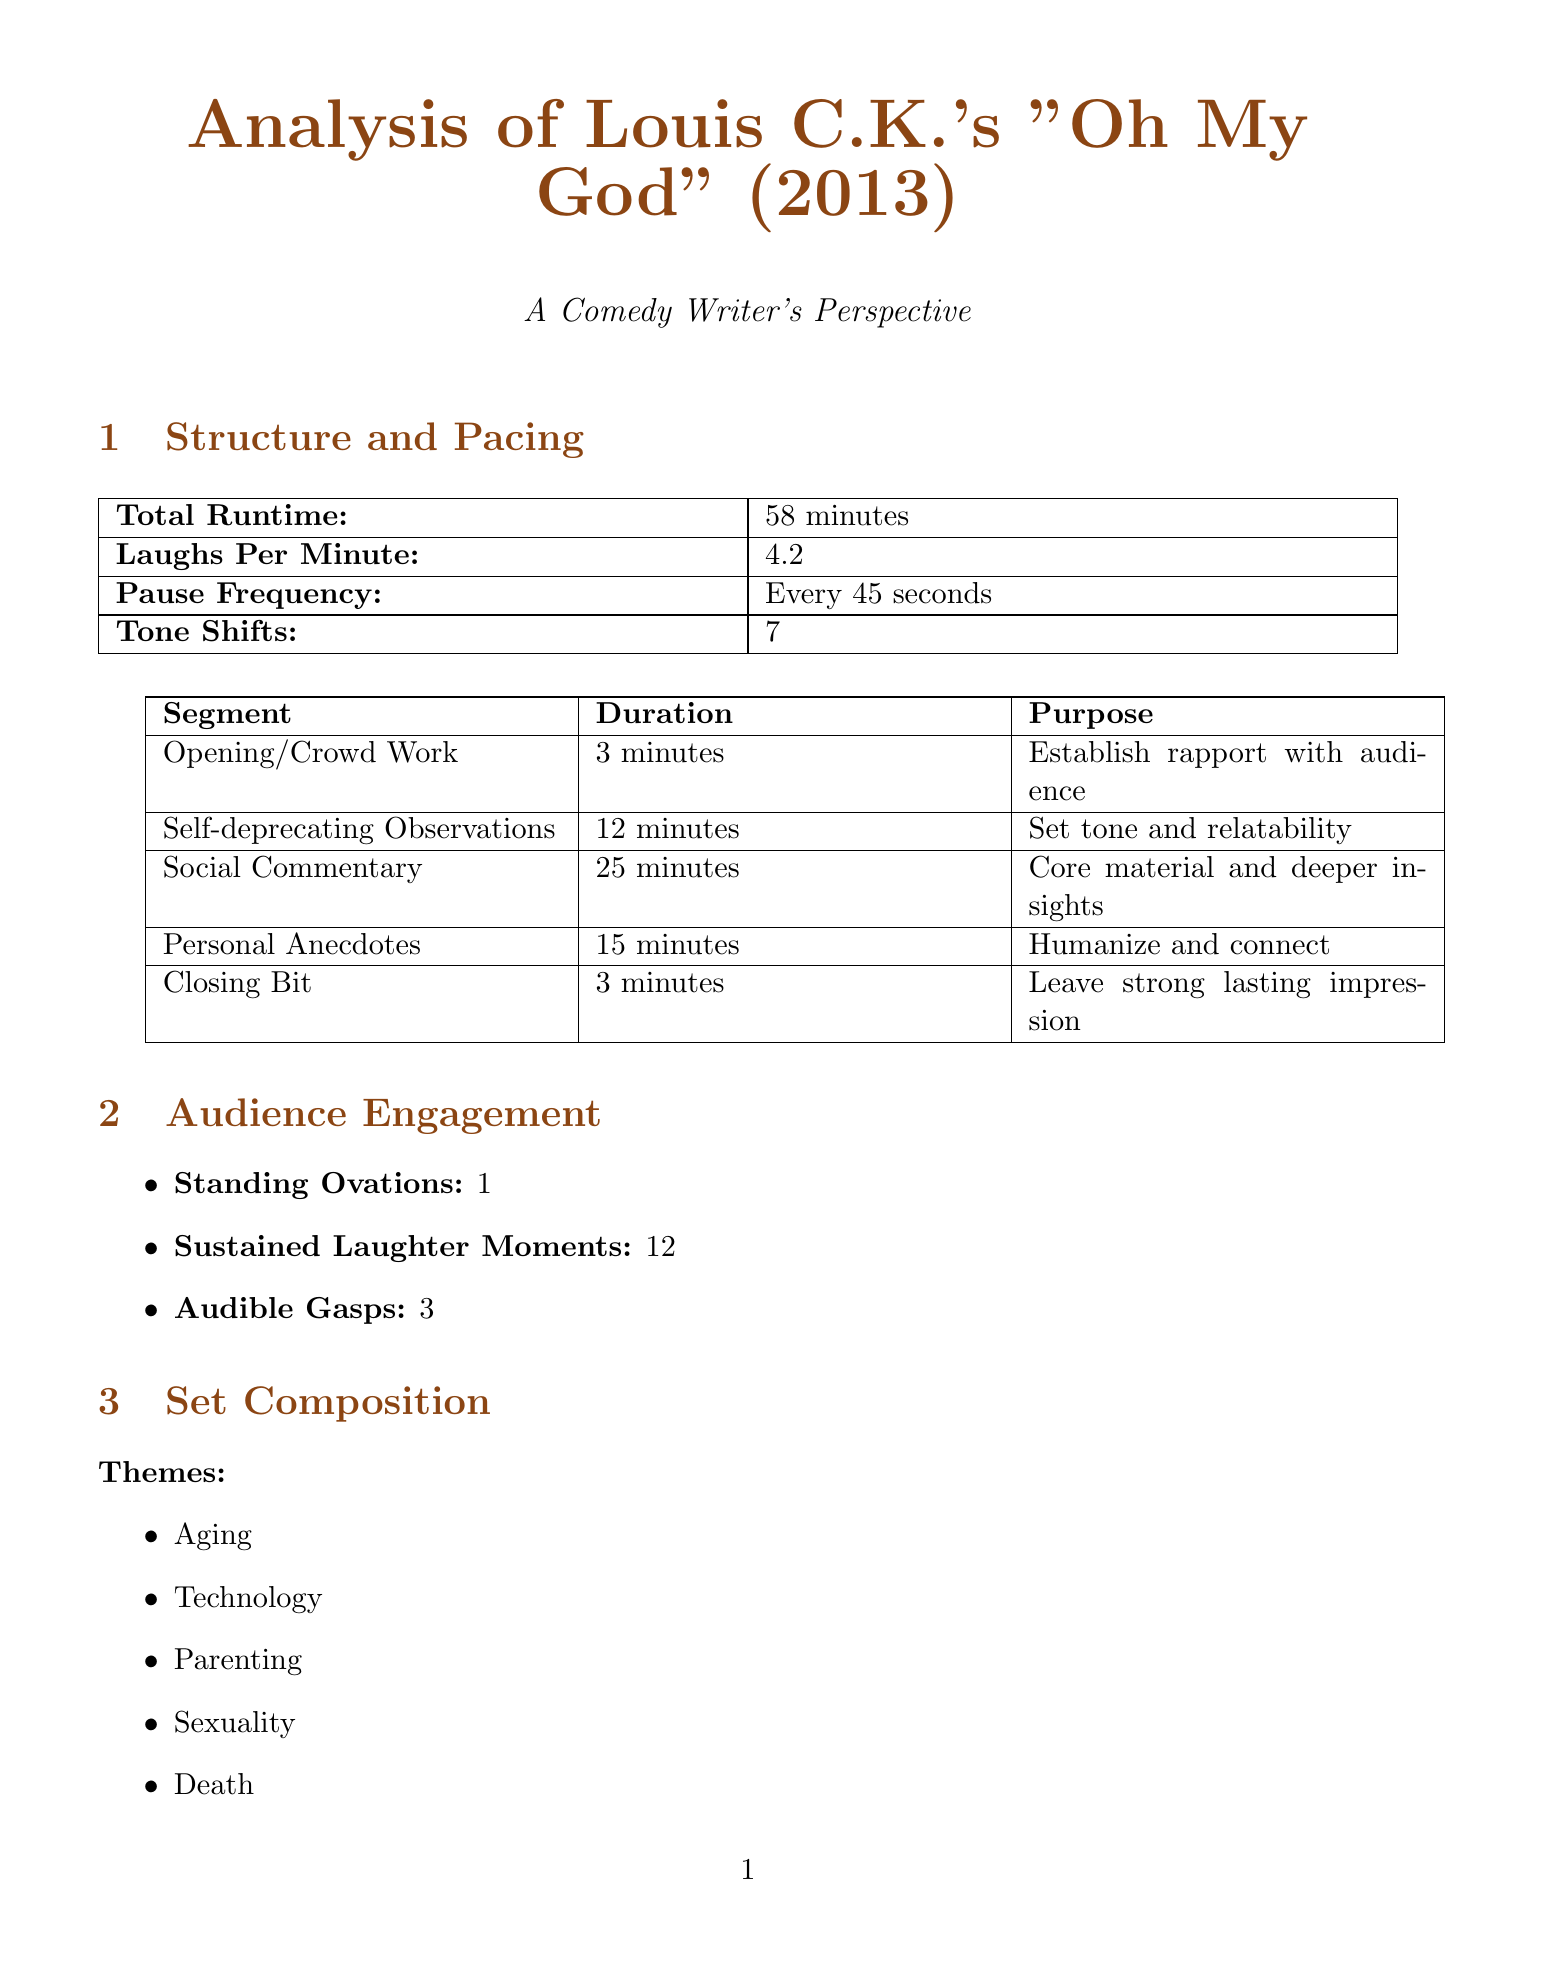What is the total runtime of Louis C.K.'s special? The total runtime is reported in the document as 58 minutes.
Answer: 58 minutes How many times did the audience sustain laughter? The document states that there were 12 moments of sustained laughter during the special.
Answer: 12 What is the audience satisfaction score? The audience satisfaction score is explicitly mentioned in the document as 8.7.
Answer: 8.7 Which writing technique involves referencing earlier jokes? The technique that involves referencing earlier jokes is called "Callback."
Answer: Callback How many themes were identified in the set composition? The document lists five themes in the set composition.
Answer: 5 What is the average number of laughs per minute? The average number of laughs per minute is stated as 4.2 in the document.
Answer: 4.2 What percentage of the audience is aged between 18 and 34? The document specifies that 45% of the audience falls within the 18 to 34 age range.
Answer: 45% Which comedian's special is compared with Louis C.K.'s in the report? The report includes comparative analysis with Dave Chappelle's special "Sticks & Stones."
Answer: Dave Chappelle How many controversial moments were noted in the set composition? The document indicates that there were 4 controversial moments noted in the set composition.
Answer: 4 